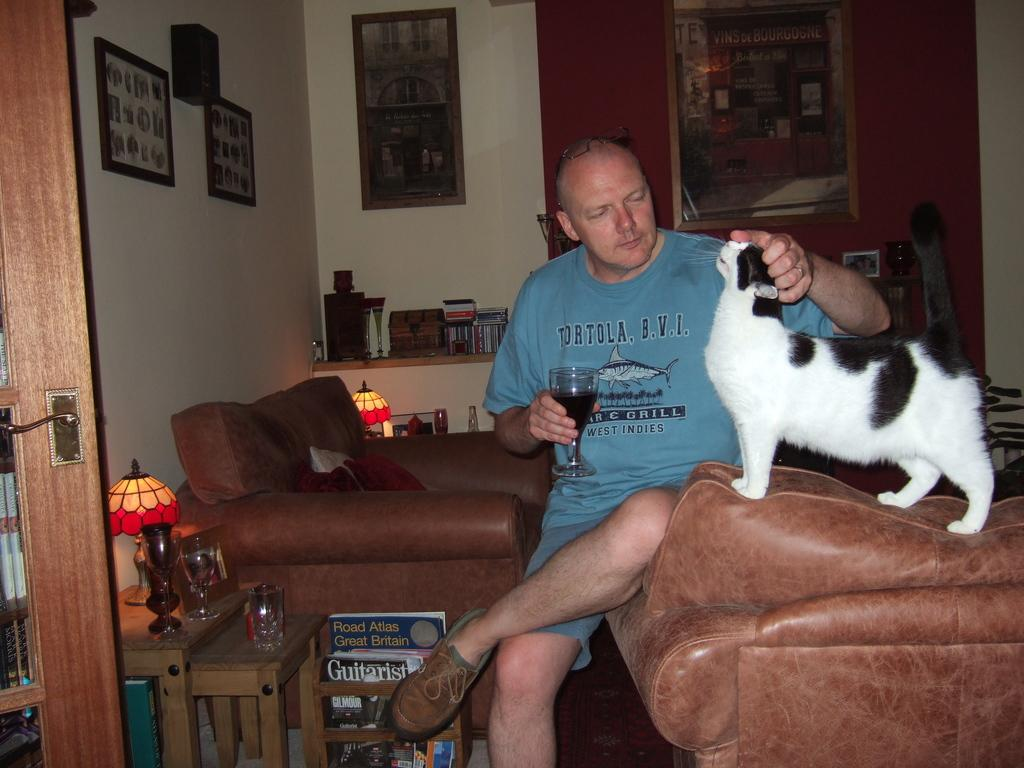<image>
Describe the image concisely. A man wearing a Tortola B.V.I.  West Indies T-Shirt sits on the edge of a couch and pets his cat while drinking a glass of wine. 